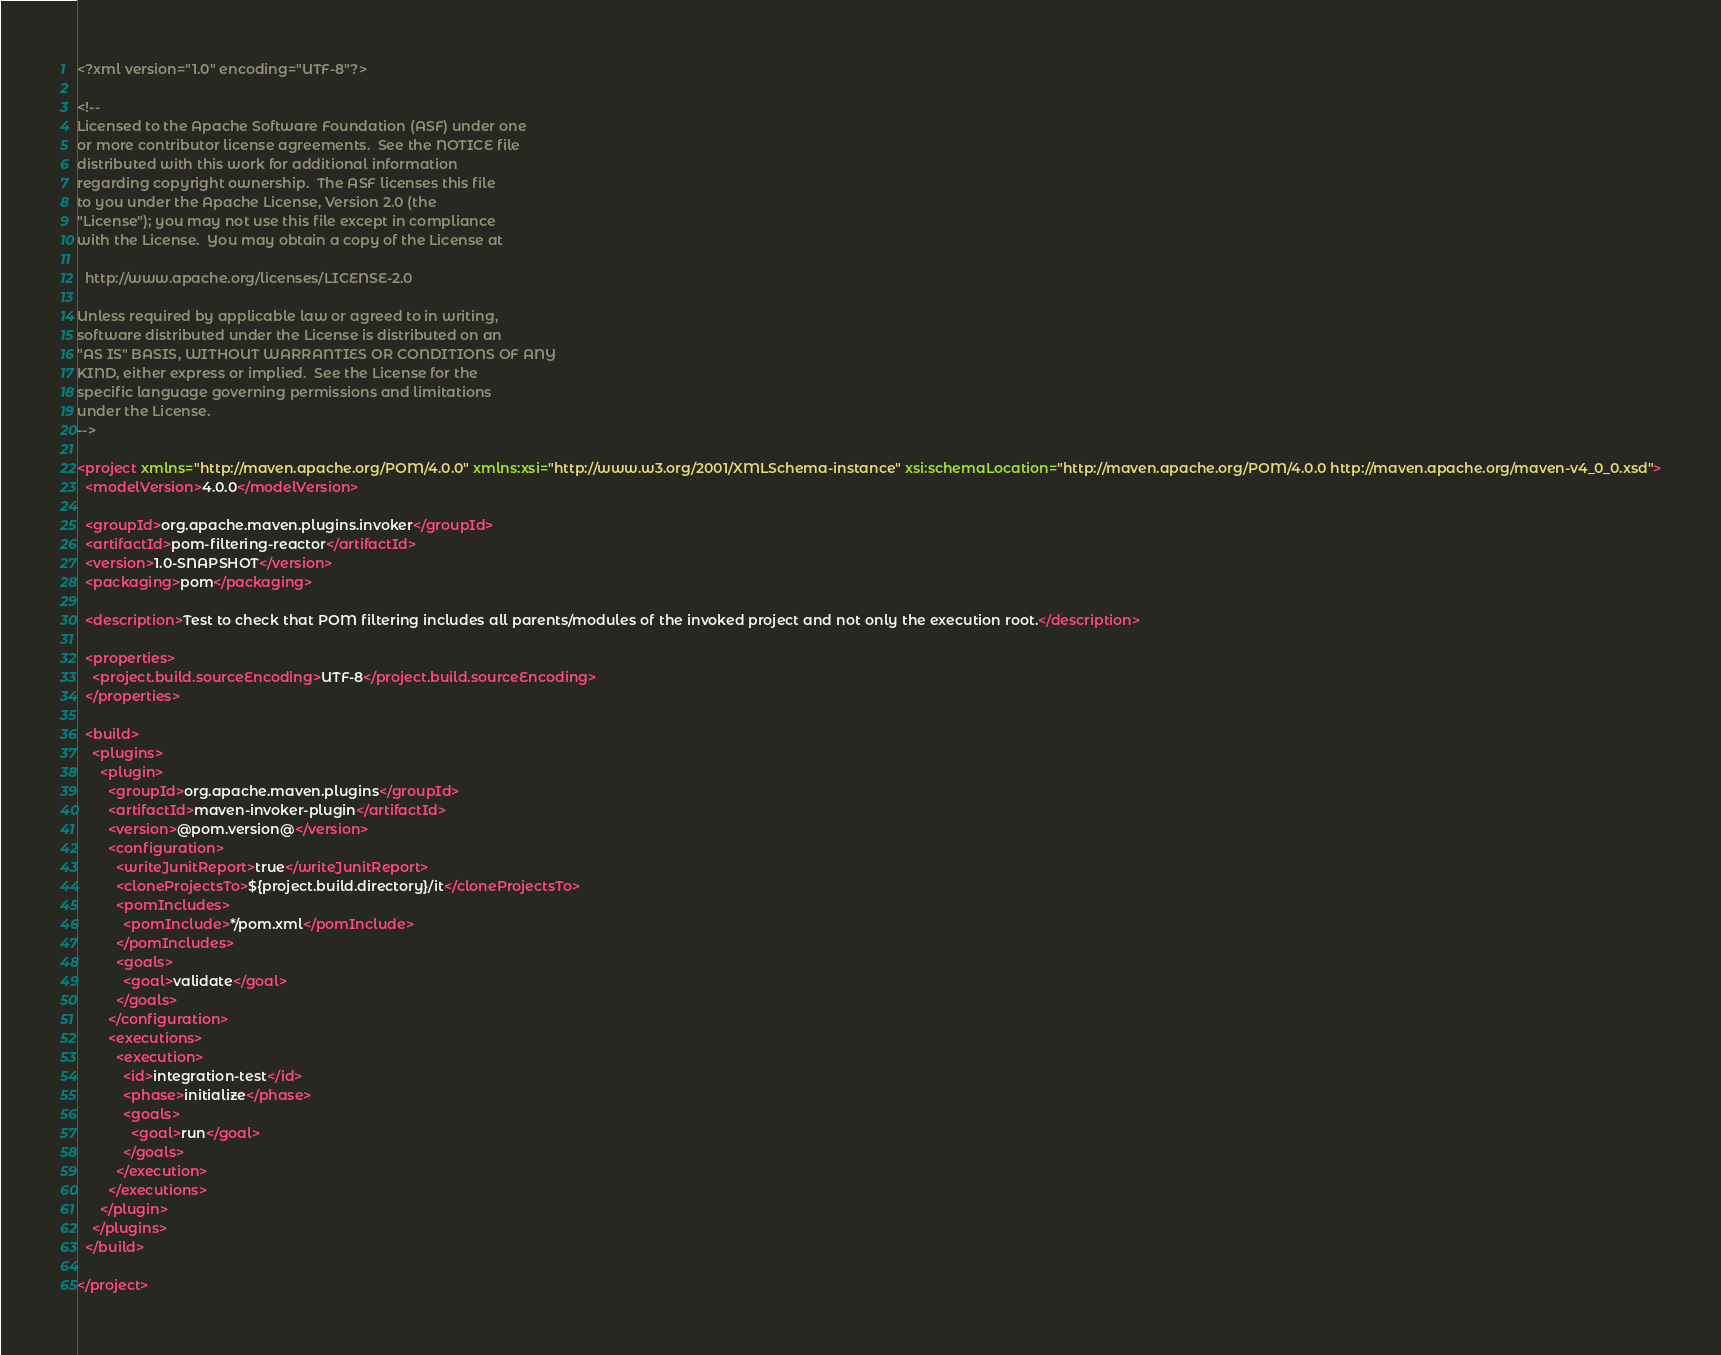<code> <loc_0><loc_0><loc_500><loc_500><_XML_><?xml version="1.0" encoding="UTF-8"?>

<!--
Licensed to the Apache Software Foundation (ASF) under one
or more contributor license agreements.  See the NOTICE file
distributed with this work for additional information
regarding copyright ownership.  The ASF licenses this file
to you under the Apache License, Version 2.0 (the
"License"); you may not use this file except in compliance
with the License.  You may obtain a copy of the License at

  http://www.apache.org/licenses/LICENSE-2.0

Unless required by applicable law or agreed to in writing,
software distributed under the License is distributed on an
"AS IS" BASIS, WITHOUT WARRANTIES OR CONDITIONS OF ANY
KIND, either express or implied.  See the License for the
specific language governing permissions and limitations
under the License.
-->

<project xmlns="http://maven.apache.org/POM/4.0.0" xmlns:xsi="http://www.w3.org/2001/XMLSchema-instance" xsi:schemaLocation="http://maven.apache.org/POM/4.0.0 http://maven.apache.org/maven-v4_0_0.xsd">
  <modelVersion>4.0.0</modelVersion>

  <groupId>org.apache.maven.plugins.invoker</groupId>
  <artifactId>pom-filtering-reactor</artifactId>
  <version>1.0-SNAPSHOT</version>
  <packaging>pom</packaging>

  <description>Test to check that POM filtering includes all parents/modules of the invoked project and not only the execution root.</description>

  <properties>
    <project.build.sourceEncoding>UTF-8</project.build.sourceEncoding>
  </properties>

  <build>
    <plugins>
      <plugin>
        <groupId>org.apache.maven.plugins</groupId>
        <artifactId>maven-invoker-plugin</artifactId>
        <version>@pom.version@</version>
        <configuration>
          <writeJunitReport>true</writeJunitReport>
          <cloneProjectsTo>${project.build.directory}/it</cloneProjectsTo>
          <pomIncludes>
            <pomInclude>*/pom.xml</pomInclude>
          </pomIncludes>
          <goals>
            <goal>validate</goal>
          </goals>
        </configuration>
        <executions>
          <execution>
            <id>integration-test</id>
            <phase>initialize</phase>
            <goals>
              <goal>run</goal>
            </goals>
          </execution>
        </executions>
      </plugin>
    </plugins>
  </build>

</project>
</code> 